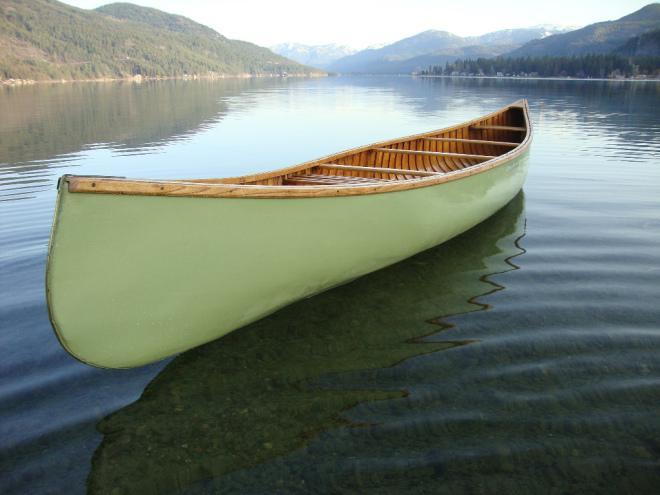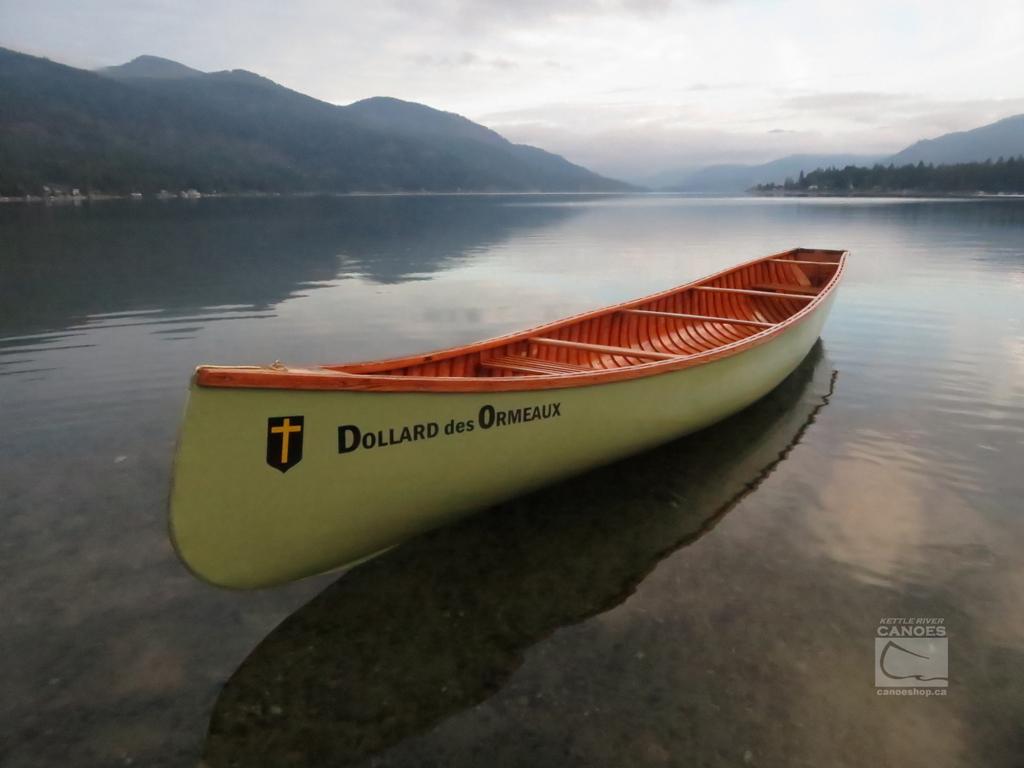The first image is the image on the left, the second image is the image on the right. Evaluate the accuracy of this statement regarding the images: "Both images contain a canoe that is turned toward the right side of the photo.". Is it true? Answer yes or no. No. 